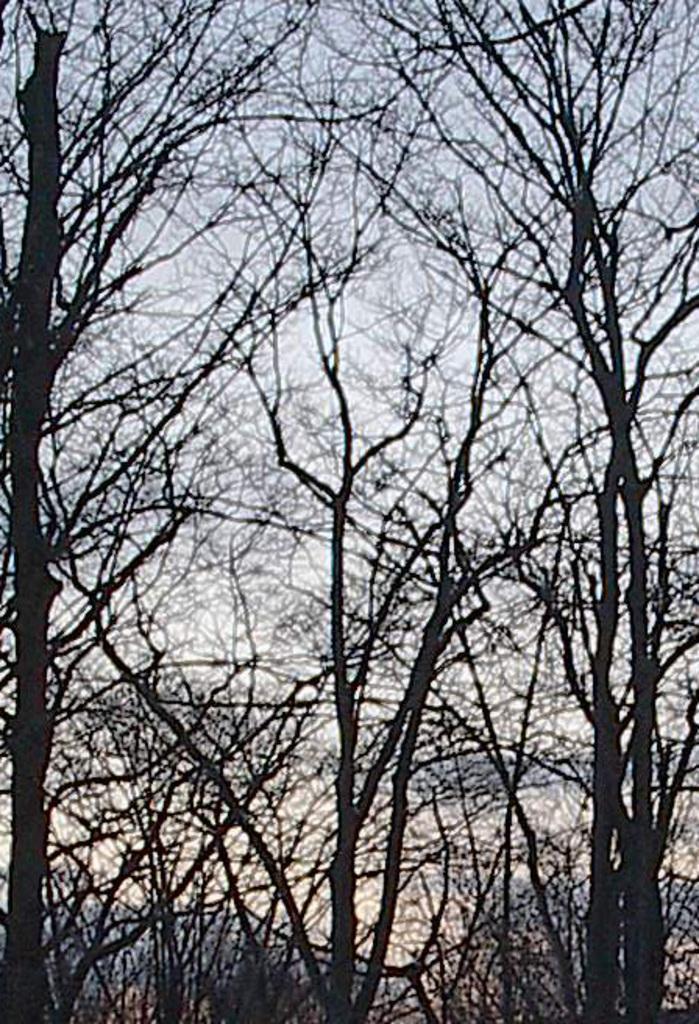In one or two sentences, can you explain what this image depicts? In this image, we can see some trees and we can see the sky. 